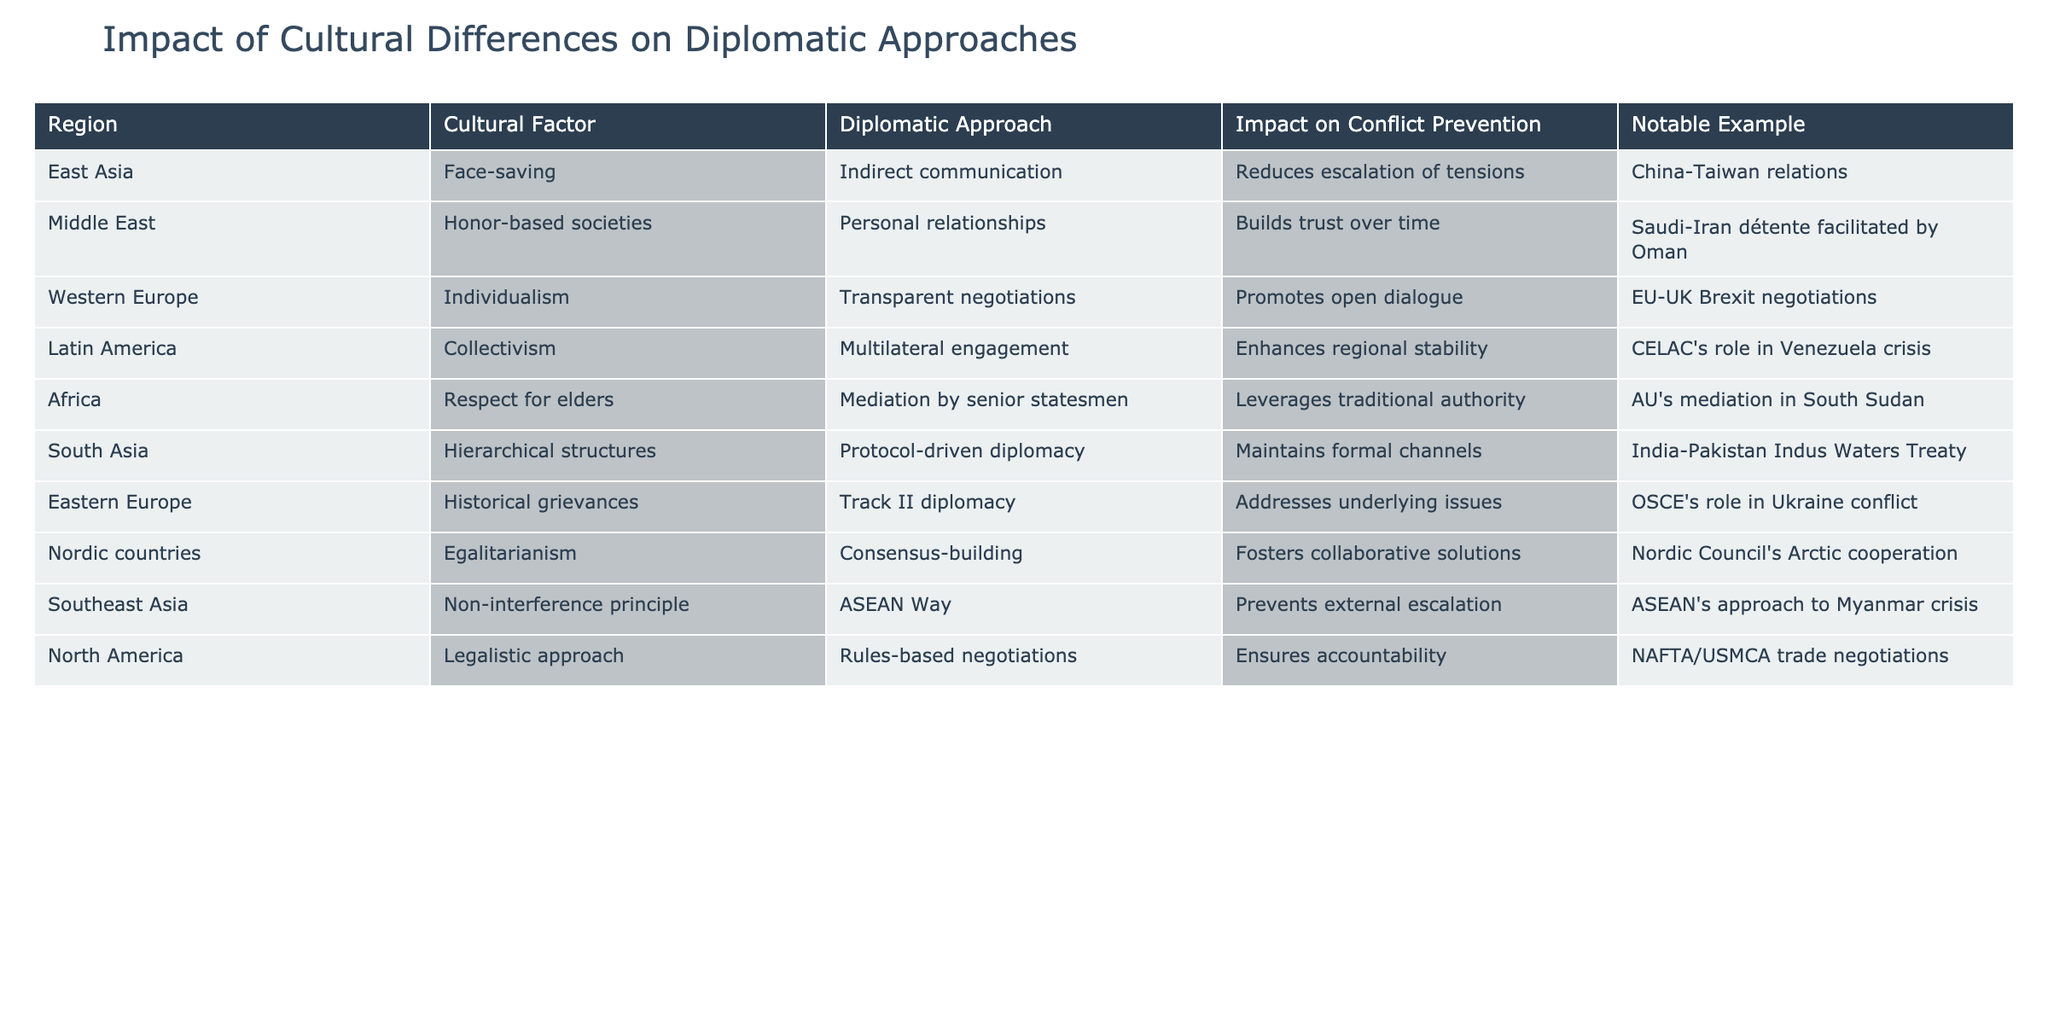What is the diplomatic approach utilized in Western Europe? The table indicates that the diplomatic approach in Western Europe is transparent negotiations. This can be found directly in the corresponding row for the region.
Answer: Transparent negotiations Which region employs a mediation strategy by senior statesmen? Looking at the "Diplomatic Approach" column for Africa, it states that mediation is done by senior statesmen. This can be verified by locating the row for Africa.
Answer: Mediation by senior statesmen How many regions utilize a consensus-building diplomatic approach? The table shows that the Nordic countries specifically use a consensus-building approach. Since only one row corresponds to this diplomatic approach, the total count is one.
Answer: 1 Is the impact on conflict prevention in Southeast Asia focused on preventing external escalation? Yes, the table states that the impact of the ASEAN Way in Southeast Asia is to prevent external escalation. This is directly stated in the row for Southeast Asia.
Answer: Yes Which region's diplomatic approach enhances regional stability? According to the table, Latin America's diplomatic approach of multilateral engagement is aimed at enhancing regional stability. This information is found in the relevant row for Latin America.
Answer: Multilateral engagement What is the notable example of face-saving in East Asia? The notable example provided for East Asia's face-saving cultural factor is the China-Taiwan relations. This is explicitly mentioned in the corresponding row for East Asia.
Answer: China-Taiwan relations Do individualism and transparent negotiations positively correlate in conflict prevention? The table suggests that individualism in Western Europe, which is associated with transparent negotiations, promotes open dialogue. Thus, it implies a positive correlation in the context of conflict prevention.
Answer: Yes What diplomatic approach is used in South Asia and what is its primary impact? In South Asia, the table lists a protocol-driven diplomacy approach, which helps maintain formal channels. This can be verified by looking at the row for South Asia, where both the approach and its impact are specified.
Answer: Protocol-driven diplomacy; maintains formal channels Which cultural factor is associated with the mediation approach in Africa? The cultural factor linked to the mediation approach in Africa is respect for elders, as stated in the respective row of the table. This connection can be clearly drawn from the information presented.
Answer: Respect for elders 